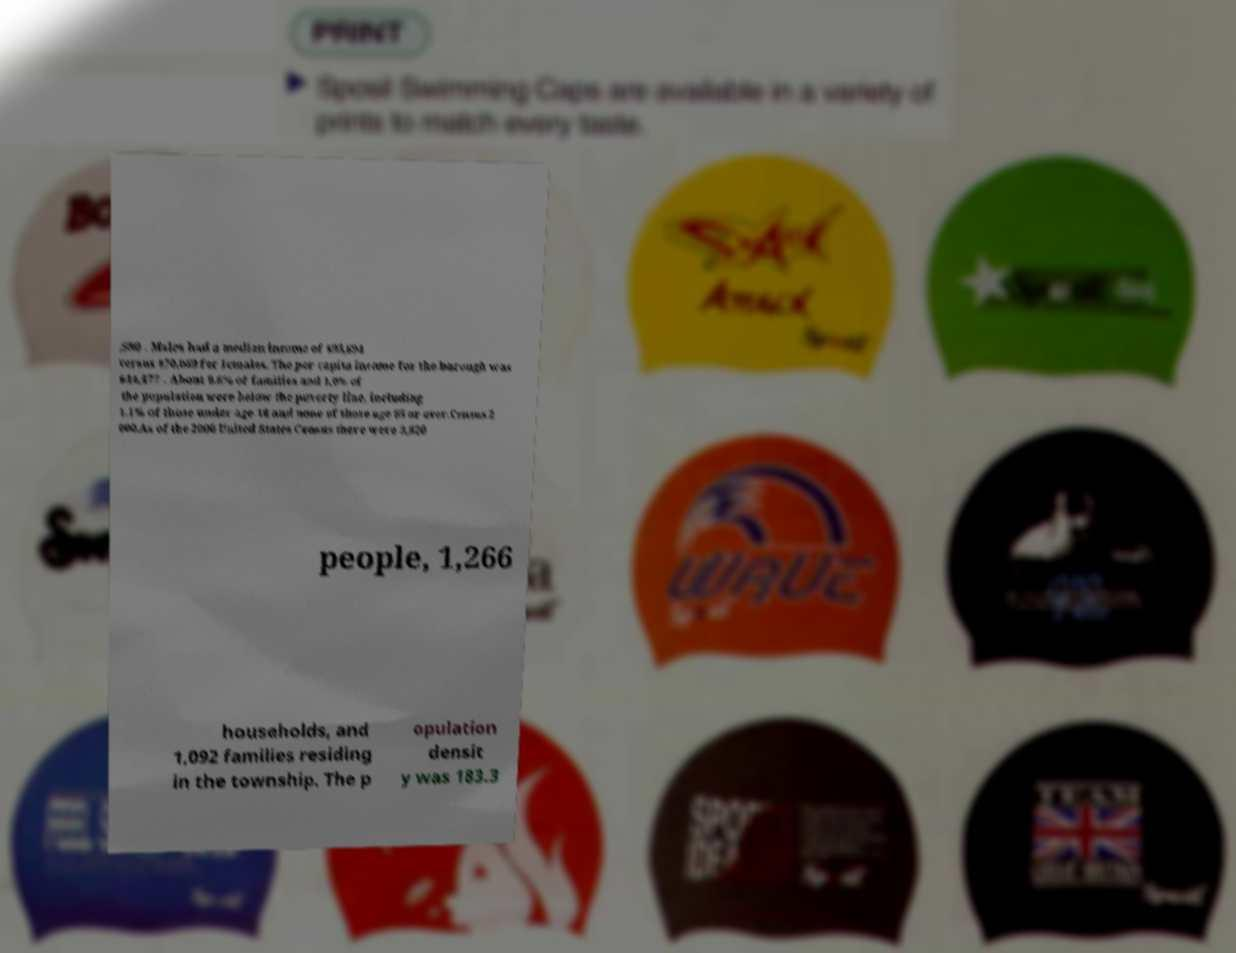Can you accurately transcribe the text from the provided image for me? ,580 . Males had a median income of $95,694 versus $70,069 for females. The per capita income for the borough was $44,477 . About 0.6% of families and 1.0% of the population were below the poverty line, including 1.1% of those under age 18 and none of those age 65 or over.Census 2 000.As of the 2000 United States Census there were 3,820 people, 1,266 households, and 1,092 families residing in the township. The p opulation densit y was 183.3 